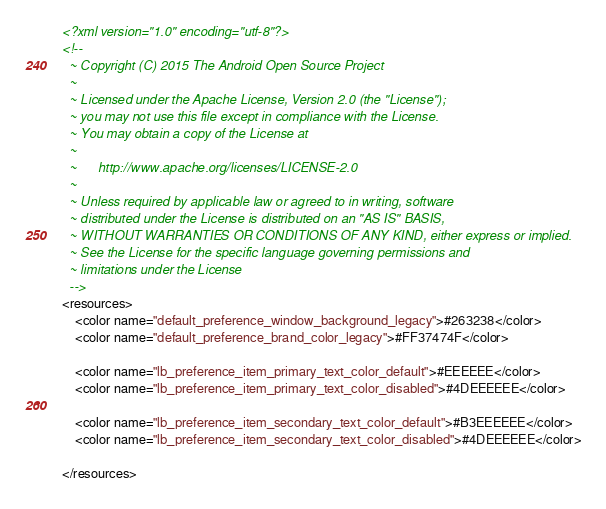<code> <loc_0><loc_0><loc_500><loc_500><_XML_><?xml version="1.0" encoding="utf-8"?>
<!--
  ~ Copyright (C) 2015 The Android Open Source Project
  ~
  ~ Licensed under the Apache License, Version 2.0 (the "License");
  ~ you may not use this file except in compliance with the License.
  ~ You may obtain a copy of the License at
  ~
  ~      http://www.apache.org/licenses/LICENSE-2.0
  ~
  ~ Unless required by applicable law or agreed to in writing, software
  ~ distributed under the License is distributed on an "AS IS" BASIS,
  ~ WITHOUT WARRANTIES OR CONDITIONS OF ANY KIND, either express or implied.
  ~ See the License for the specific language governing permissions and
  ~ limitations under the License
  -->
<resources>
    <color name="default_preference_window_background_legacy">#263238</color>
    <color name="default_preference_brand_color_legacy">#FF37474F</color>

    <color name="lb_preference_item_primary_text_color_default">#EEEEEE</color>
    <color name="lb_preference_item_primary_text_color_disabled">#4DEEEEEE</color>

    <color name="lb_preference_item_secondary_text_color_default">#B3EEEEEE</color>
    <color name="lb_preference_item_secondary_text_color_disabled">#4DEEEEEE</color>

</resources>
</code> 